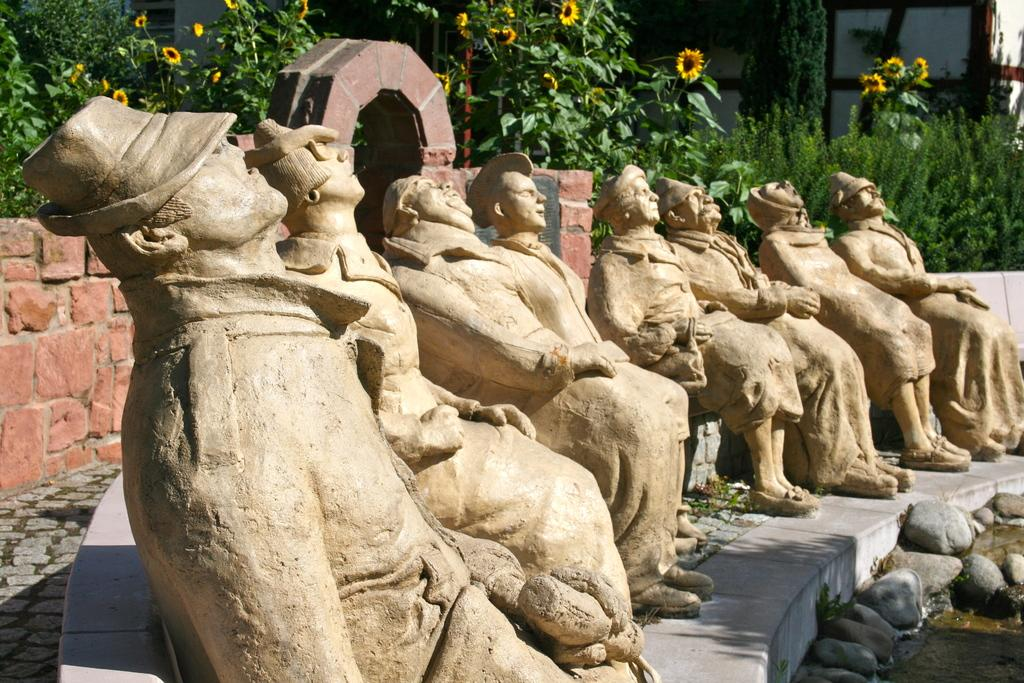What type of objects are depicted as statues in the image? There are statues of people in the image. What material is present in the image? There are stones in the image. What natural element can be seen in the image? Water is visible in the image. What type of flowers are present in the image? Sunflowers are present in the image. What type of vegetation is present in the image? There are plants in the image. What type of structure is visible in the image? There is a wall in the image. How many yaks are visible in the image? There are no yaks present in the image. What level of expertise does the monkey have in the image? There are no monkeys present in the image. 